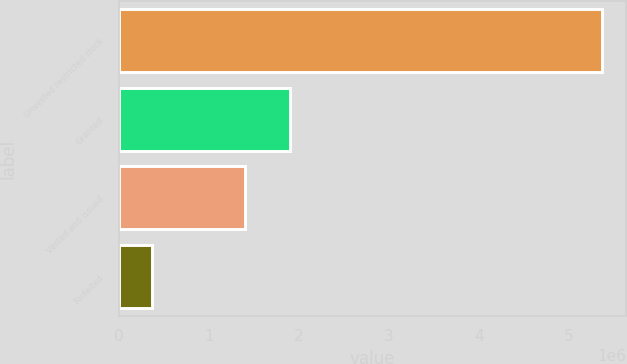Convert chart. <chart><loc_0><loc_0><loc_500><loc_500><bar_chart><fcel>Unvested restricted stock<fcel>Granted<fcel>Vested and issued<fcel>Forfeited<nl><fcel>5.36688e+06<fcel>1.89728e+06<fcel>1.40383e+06<fcel>371183<nl></chart> 